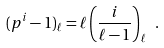<formula> <loc_0><loc_0><loc_500><loc_500>( p ^ { i } - 1 ) _ { \ell } = \ell \left ( \frac { i } { \ell - 1 } \right ) _ { \ell } \ .</formula> 